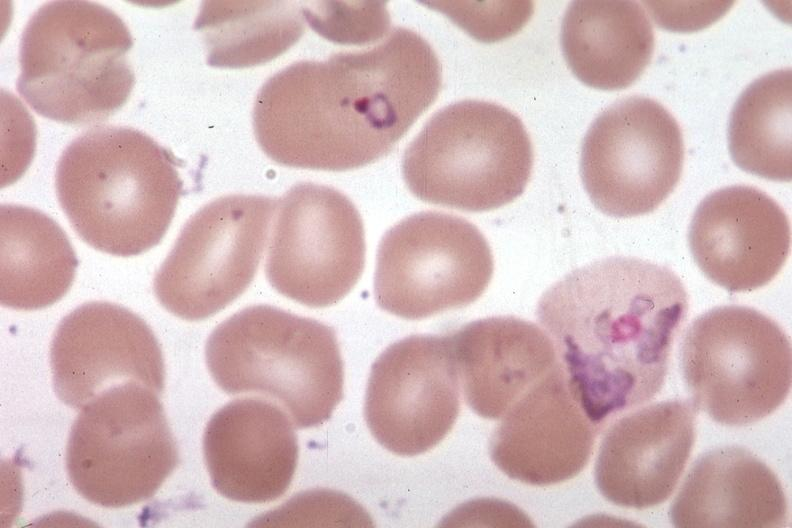does this image show oil wrights very good?
Answer the question using a single word or phrase. Yes 